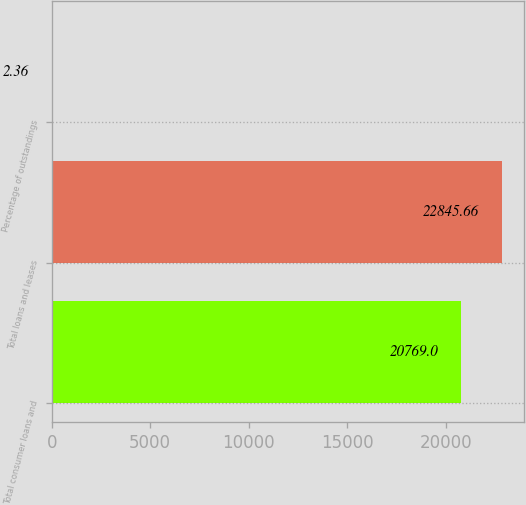Convert chart. <chart><loc_0><loc_0><loc_500><loc_500><bar_chart><fcel>Total consumer loans and<fcel>Total loans and leases<fcel>Percentage of outstandings<nl><fcel>20769<fcel>22845.7<fcel>2.36<nl></chart> 